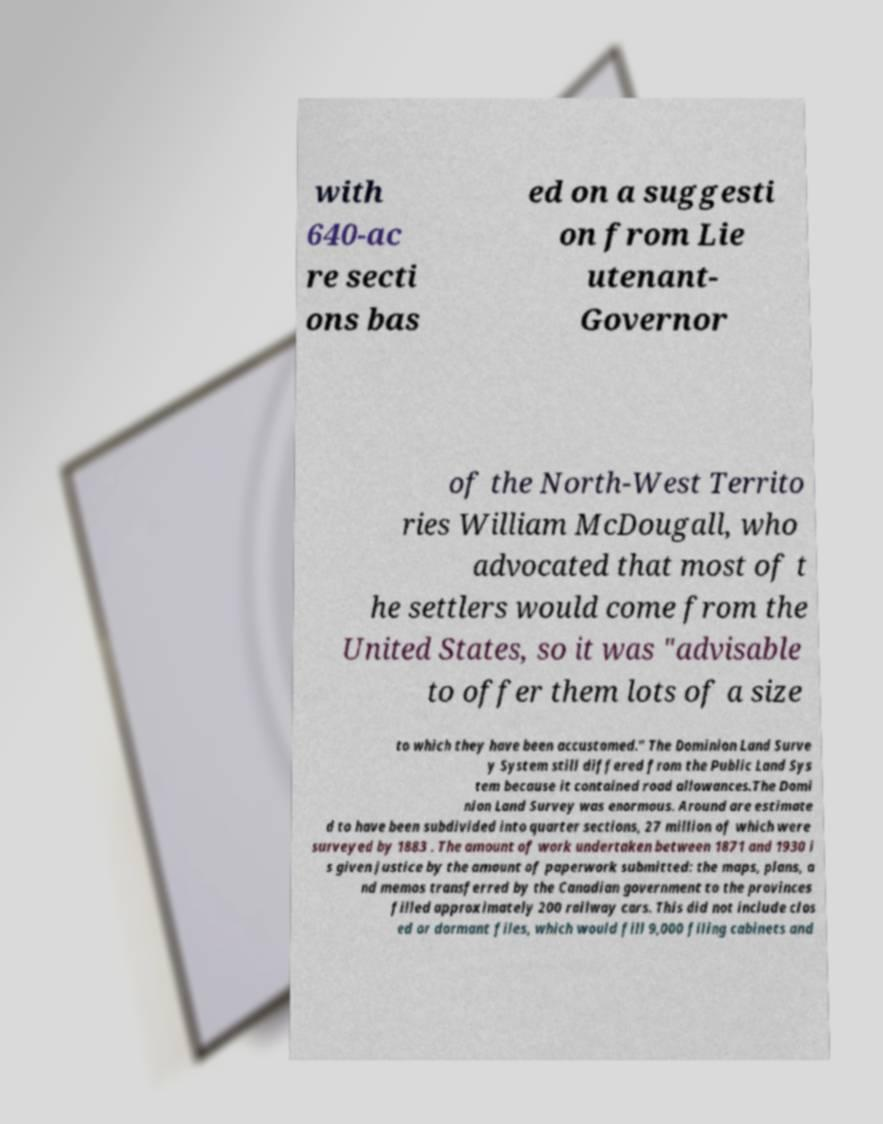Please identify and transcribe the text found in this image. with 640-ac re secti ons bas ed on a suggesti on from Lie utenant- Governor of the North-West Territo ries William McDougall, who advocated that most of t he settlers would come from the United States, so it was "advisable to offer them lots of a size to which they have been accustomed." The Dominion Land Surve y System still differed from the Public Land Sys tem because it contained road allowances.The Domi nion Land Survey was enormous. Around are estimate d to have been subdivided into quarter sections, 27 million of which were surveyed by 1883 . The amount of work undertaken between 1871 and 1930 i s given justice by the amount of paperwork submitted: the maps, plans, a nd memos transferred by the Canadian government to the provinces filled approximately 200 railway cars. This did not include clos ed or dormant files, which would fill 9,000 filing cabinets and 